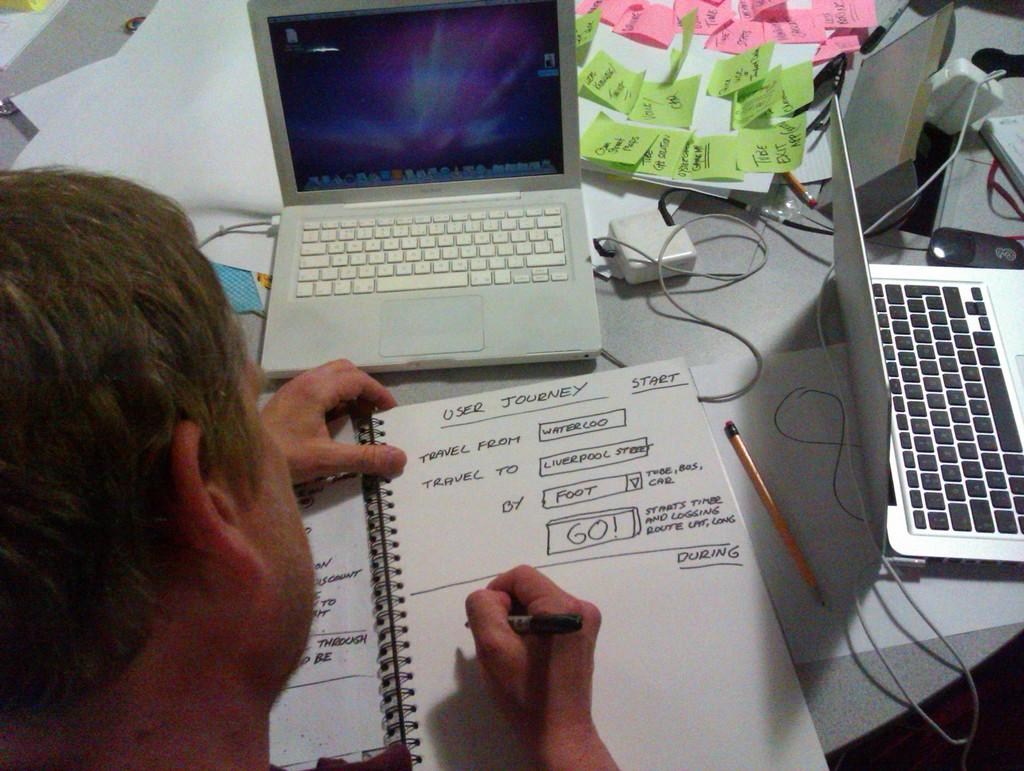<image>
Write a terse but informative summary of the picture. the words travel that are on the paper 